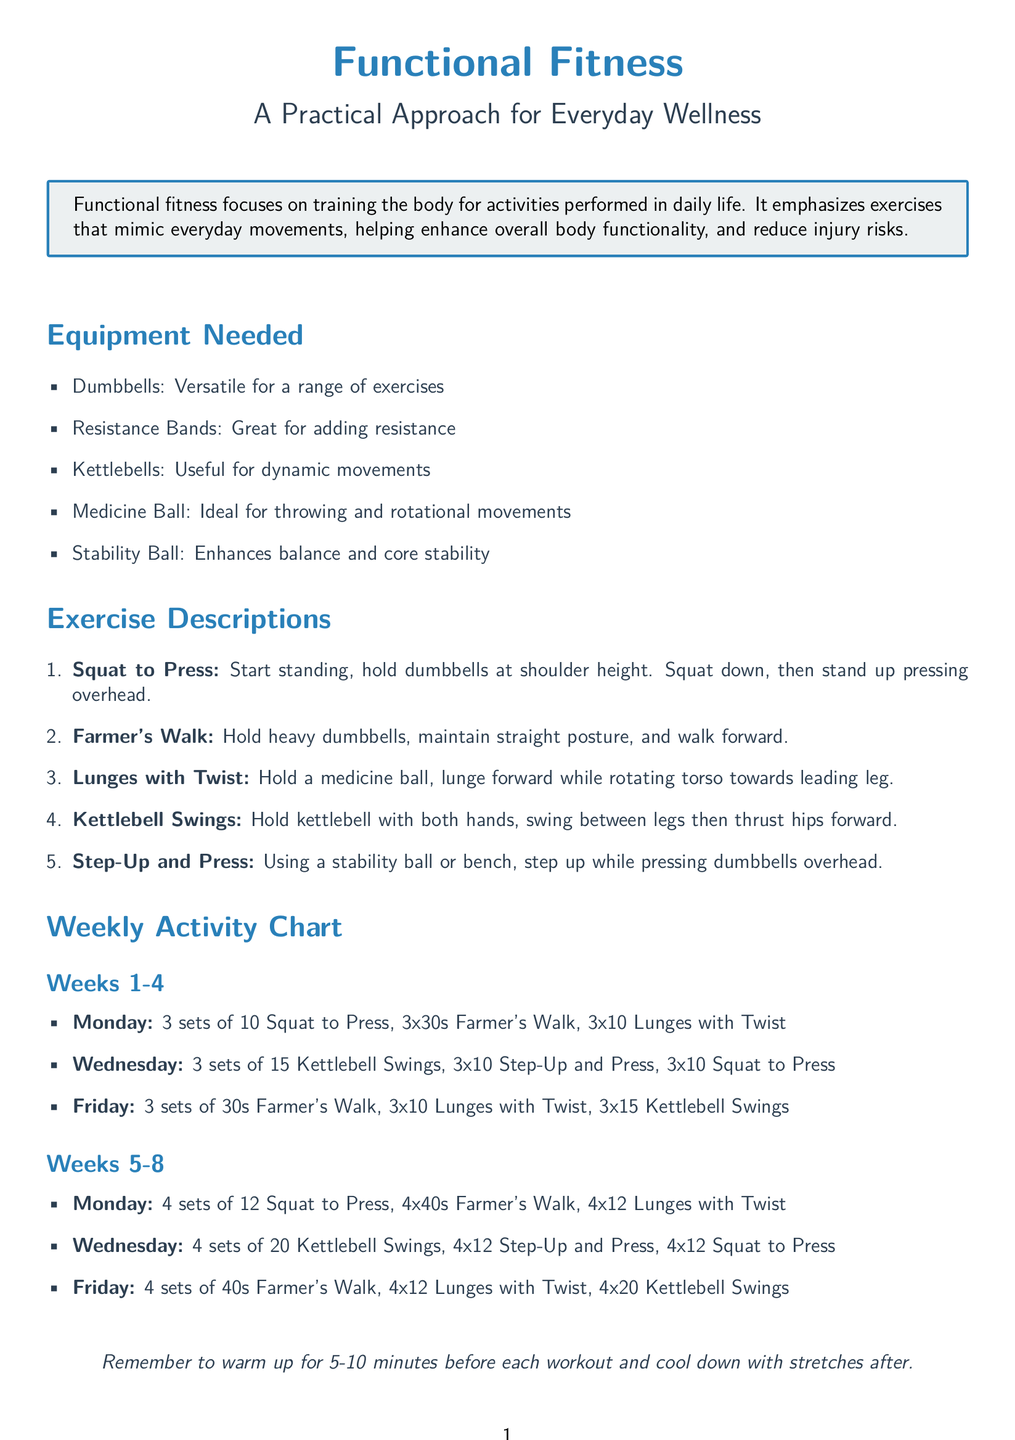What exercise mimics a squat while pressing overhead? The exercise that mimics a squat while pressing overhead is described as "Squat to Press."
Answer: Squat to Press How many kettlebell swings are performed in Weeks 5-8 on Wednesdays? The number of kettlebell swings performed in Weeks 5-8 on Wednesdays is stated in the weekly activity chart as "4 sets of 20."
Answer: 20 What piece of equipment is used for stability during exercises? The piece of equipment used for stability during exercises is a "Stability Ball."
Answer: Stability Ball On which day of the week are lunges with a twist performed in Weeks 1-4? The day of the week when lunges with a twist are performed in Weeks 1-4 is listed in the activity chart as "Monday."
Answer: Monday How long should the Farmer's Walk be performed in Weeks 5-8? The duration for performing the Farmer's Walk in Weeks 5-8 is indicated in the document as "4x40s."
Answer: 40 seconds What is the main goal of functional fitness as stated in the document? The main goal of functional fitness as stated in the document is "enhance overall body functionality."
Answer: Enhance overall body functionality How many total exercise sessions are planned per week? The total number of exercise sessions planned per week is referenced in the weekly activity chart, indicating "3."
Answer: 3 What is recommended before each workout? The recommended activity before each workout is clearly stated as "warm up for 5-10 minutes."
Answer: Warm up for 5-10 minutes What resistance equipment is mentioned for adding difficulty to exercises? The resistance equipment mentioned for adding difficulty to exercises is "Resistance Bands."
Answer: Resistance Bands 